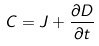<formula> <loc_0><loc_0><loc_500><loc_500>C = J + \frac { \partial D } { \partial t }</formula> 